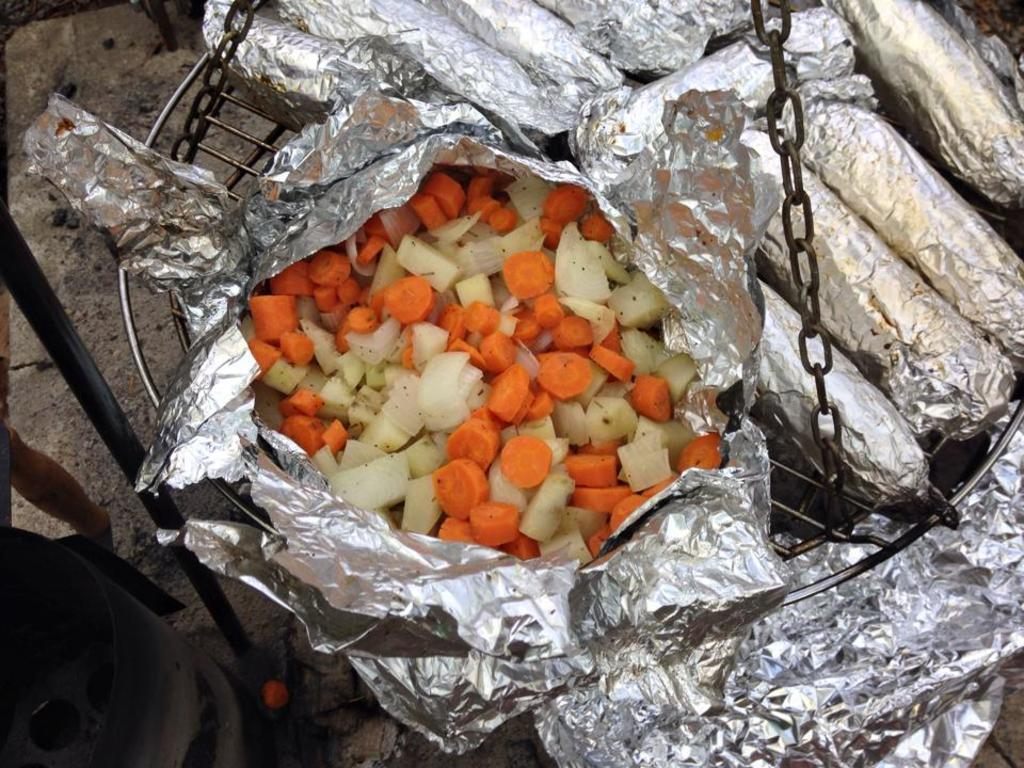What is wrapped in the aluminum foil in the image? There are vegetable slices in the aluminum foil in the image. Where is the aluminum foil placed? The aluminum foil is on a grill. What feature is present on the grill? The grill has metal chains. What can be seen on the land in the left bottom of the image? There is an object on the land in the left bottom of the image. What type of amusement can be seen on the grill in the image? There is no amusement present on the grill in the image; it is a grill with vegetable slices wrapped in aluminum foil and metal chains. Can you tell me what wish the vegetable slices are making in the image? Vegetable slices do not have the ability to make wishes, so this cannot be determined from the image. 